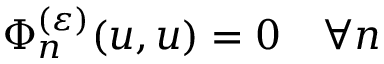Convert formula to latex. <formula><loc_0><loc_0><loc_500><loc_500>\Phi _ { n } ^ { ( \varepsilon ) } ( u , u ) = 0 \quad \forall n</formula> 